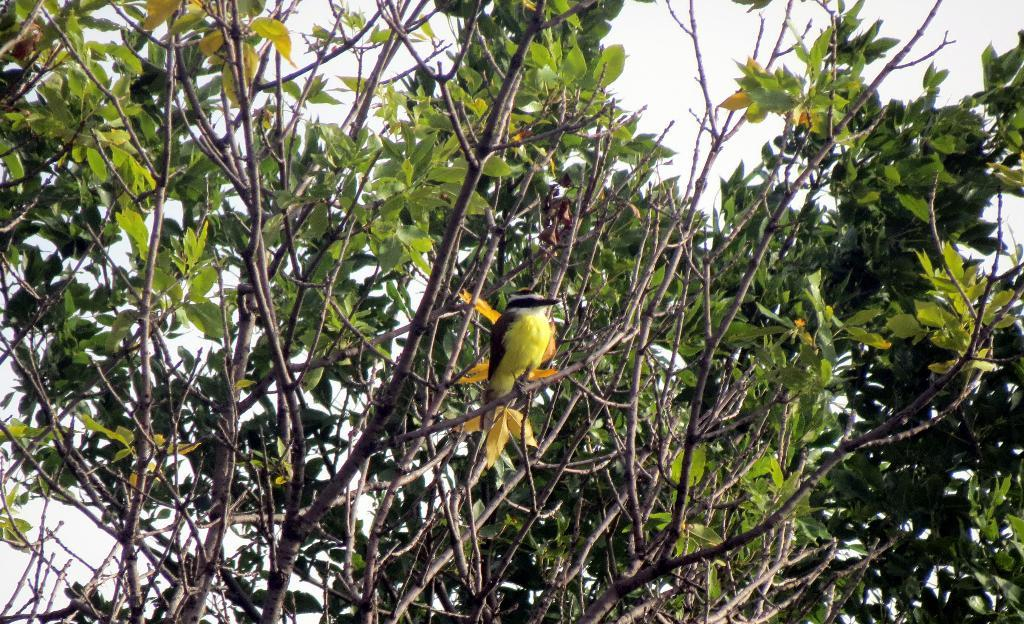What is present in the image besides the sky? There is a tree in the image. Can you describe the tree in the image? There is a bird on the tree. What can be seen in the background of the image? The sky is visible behind the tree. What type of soup is being served in the image? There is no soup present in the image; it features a tree with a bird on it and a visible sky. 